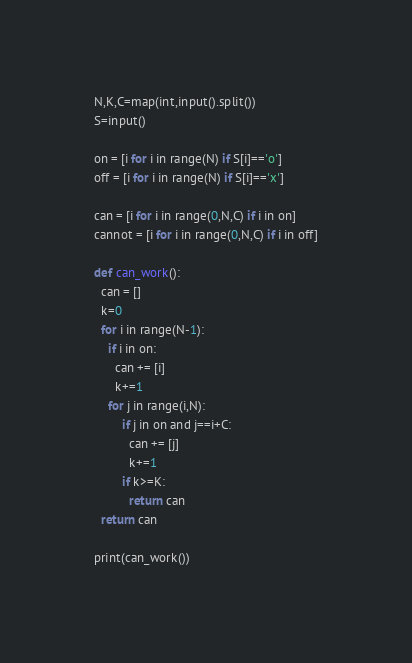<code> <loc_0><loc_0><loc_500><loc_500><_Python_>N,K,C=map(int,input().split())
S=input()

on = [i for i in range(N) if S[i]=='o']
off = [i for i in range(N) if S[i]=='x']

can = [i for i in range(0,N,C) if i in on]
cannot = [i for i in range(0,N,C) if i in off]

def can_work():
  can = []
  k=0
  for i in range(N-1):
    if i in on:
      can += [i]
      k+=1
    for j in range(i,N):
        if j in on and j==i+C:
          can += [j]
          k+=1
        if k>=K:
          return can
  return can

print(can_work())</code> 